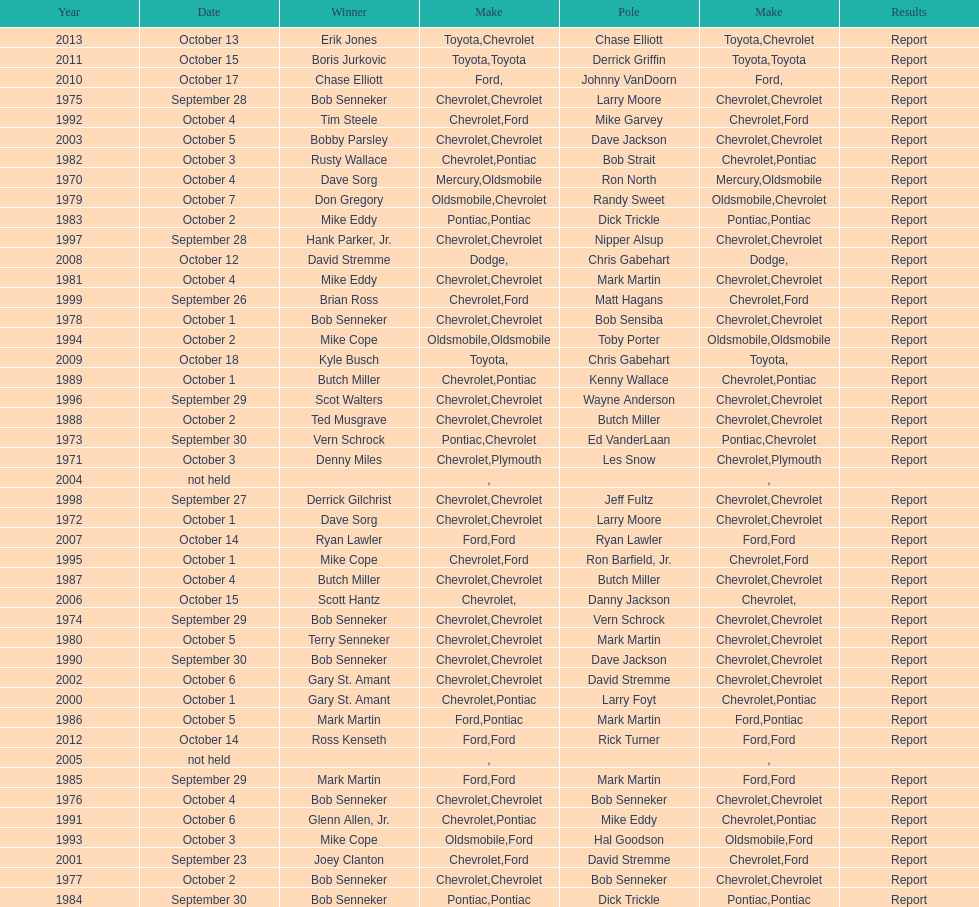Which make was used the least? Mercury. 